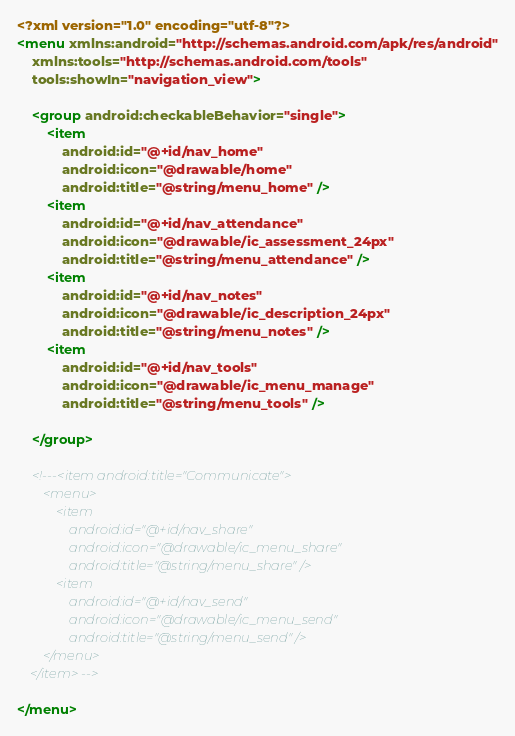Convert code to text. <code><loc_0><loc_0><loc_500><loc_500><_XML_><?xml version="1.0" encoding="utf-8"?>
<menu xmlns:android="http://schemas.android.com/apk/res/android"
    xmlns:tools="http://schemas.android.com/tools"
    tools:showIn="navigation_view">

    <group android:checkableBehavior="single">
        <item
            android:id="@+id/nav_home"
            android:icon="@drawable/home"
            android:title="@string/menu_home" />
        <item
            android:id="@+id/nav_attendance"
            android:icon="@drawable/ic_assessment_24px"
            android:title="@string/menu_attendance" />
        <item
            android:id="@+id/nav_notes"
            android:icon="@drawable/ic_description_24px"
            android:title="@string/menu_notes" />
        <item
            android:id="@+id/nav_tools"
            android:icon="@drawable/ic_menu_manage"
            android:title="@string/menu_tools" />

    </group>

    <!---<item android:title="Communicate">
        <menu>
            <item
                android:id="@+id/nav_share"
                android:icon="@drawable/ic_menu_share"
                android:title="@string/menu_share" />
            <item
                android:id="@+id/nav_send"
                android:icon="@drawable/ic_menu_send"
                android:title="@string/menu_send" />
        </menu>
    </item> -->

</menu>
</code> 